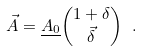<formula> <loc_0><loc_0><loc_500><loc_500>\vec { A } = \underline { A _ { 0 } } { 1 + \delta \choose \vec { \delta } } \ .</formula> 